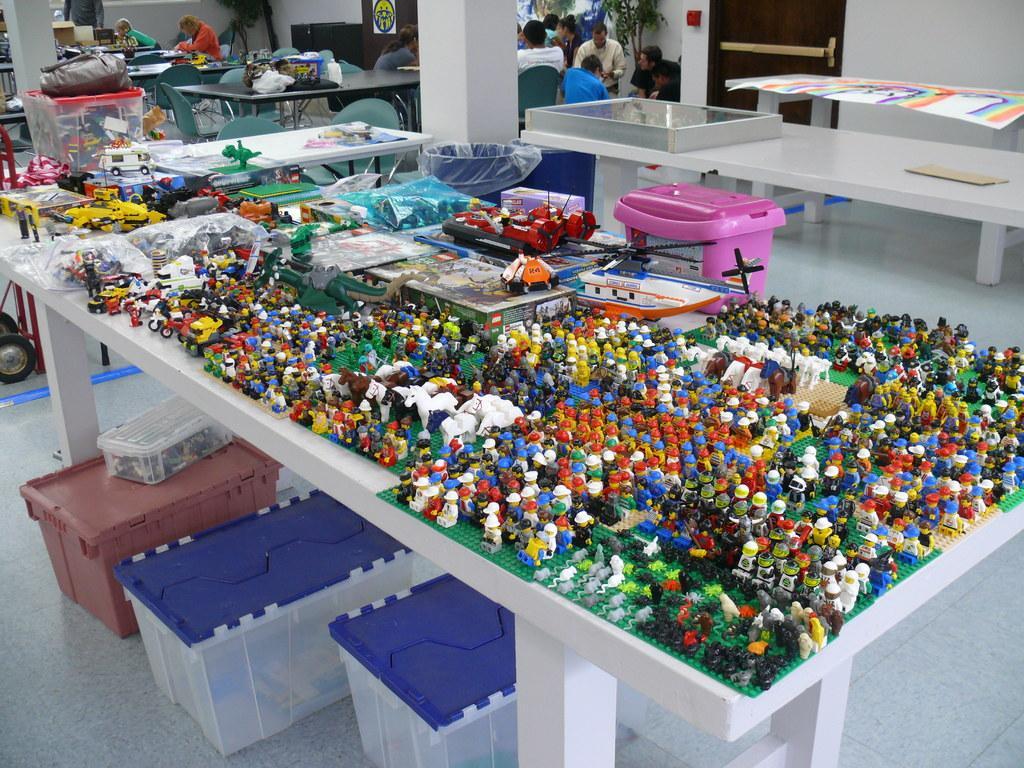In one or two sentences, can you explain what this image depicts? In the image there are lego toys on a table and below it there are three boxes on the floor, in the back there are many tables all over the place with people sitting around it. 